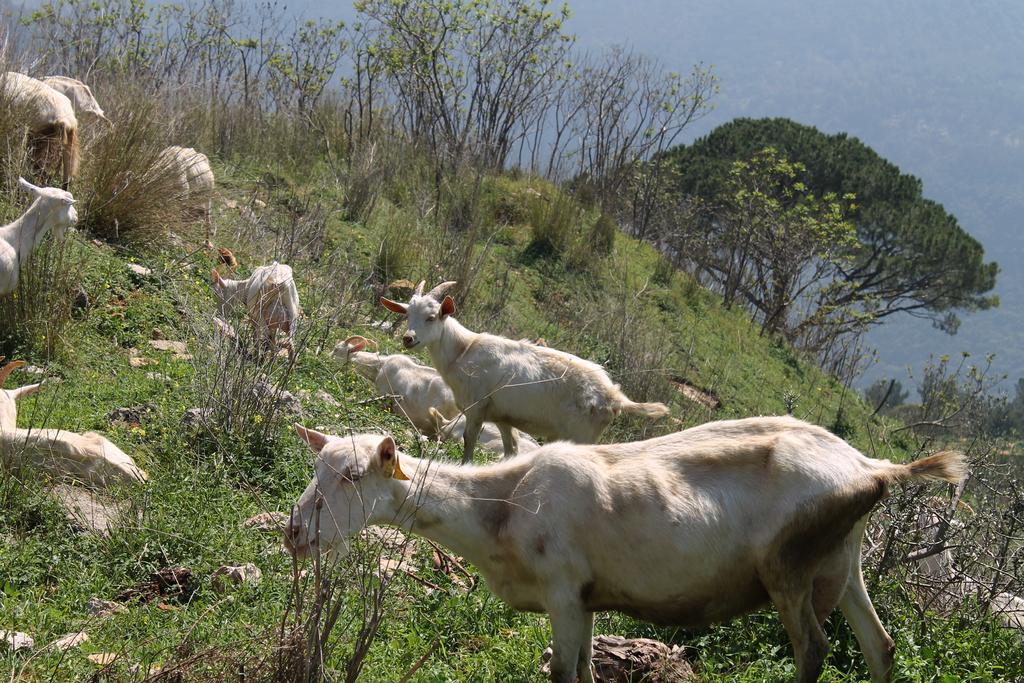Describe this image in one or two sentences. In this image, we can see goats and in the background there are trees. At the bottom, there is ground covered with plants. 